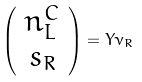<formula> <loc_0><loc_0><loc_500><loc_500>\left ( \begin{array} { c } n _ { L } ^ { C } \\ s _ { R } \end{array} \right ) = Y \nu _ { R }</formula> 